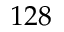<formula> <loc_0><loc_0><loc_500><loc_500>1 2 8</formula> 